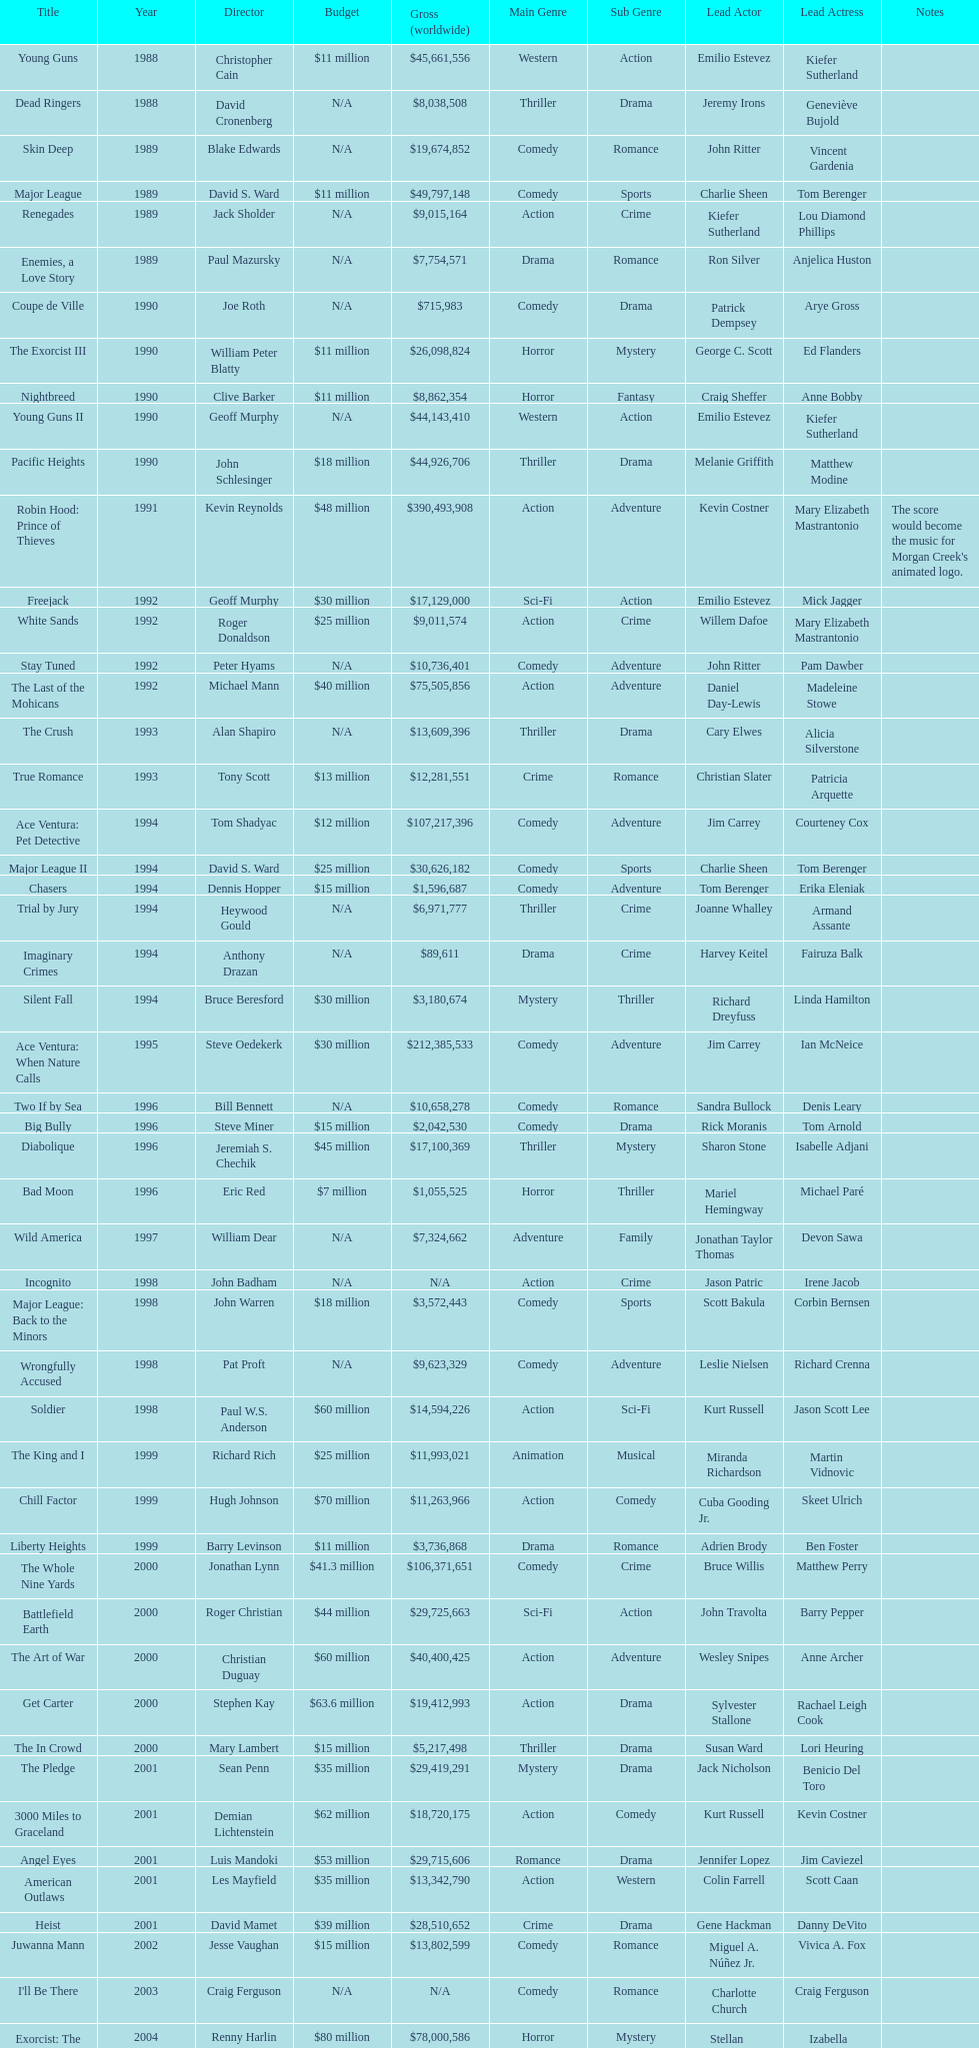How many films did morgan creek make in 2006? 2. 